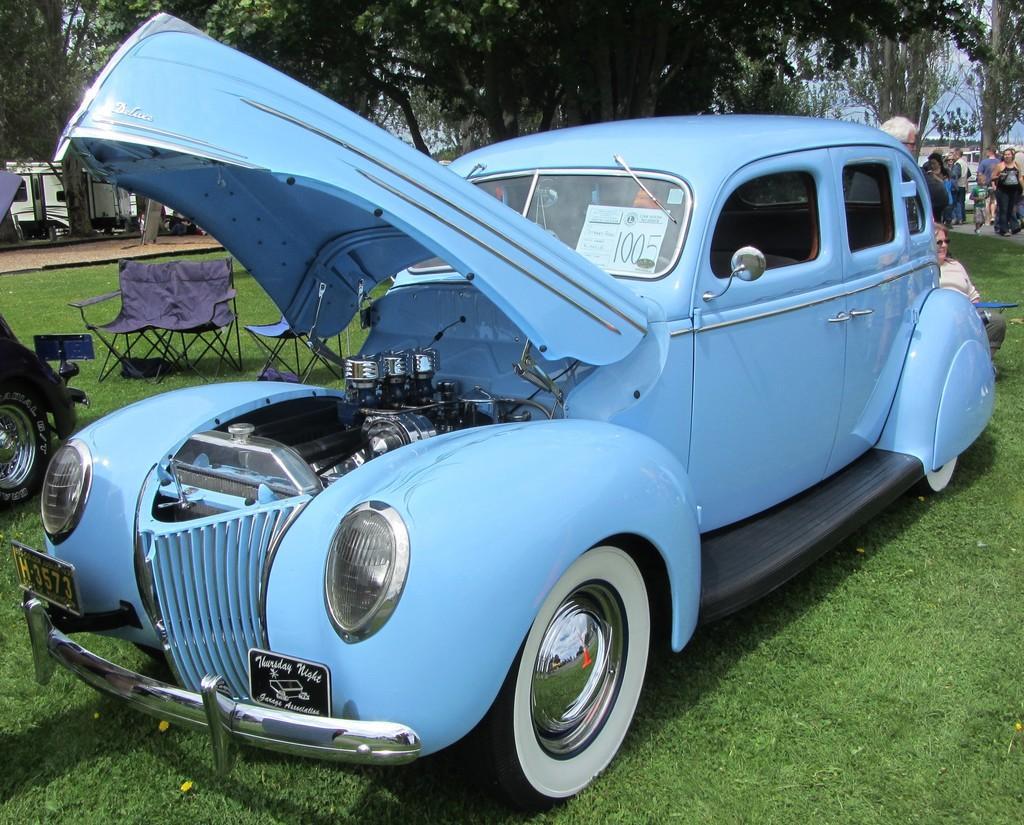Please provide a concise description of this image. There is a car. There is a poster in the car. On the ground there is grass. Also there are chairs. In the background there are trees and there are many people. On the left side there are many people. 